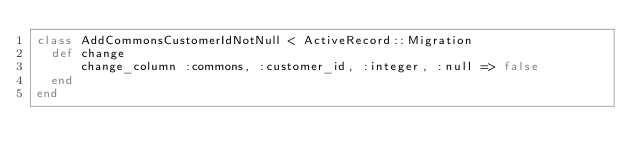Convert code to text. <code><loc_0><loc_0><loc_500><loc_500><_Ruby_>class AddCommonsCustomerIdNotNull < ActiveRecord::Migration
  def change
      change_column :commons, :customer_id, :integer, :null => false
  end
end
</code> 